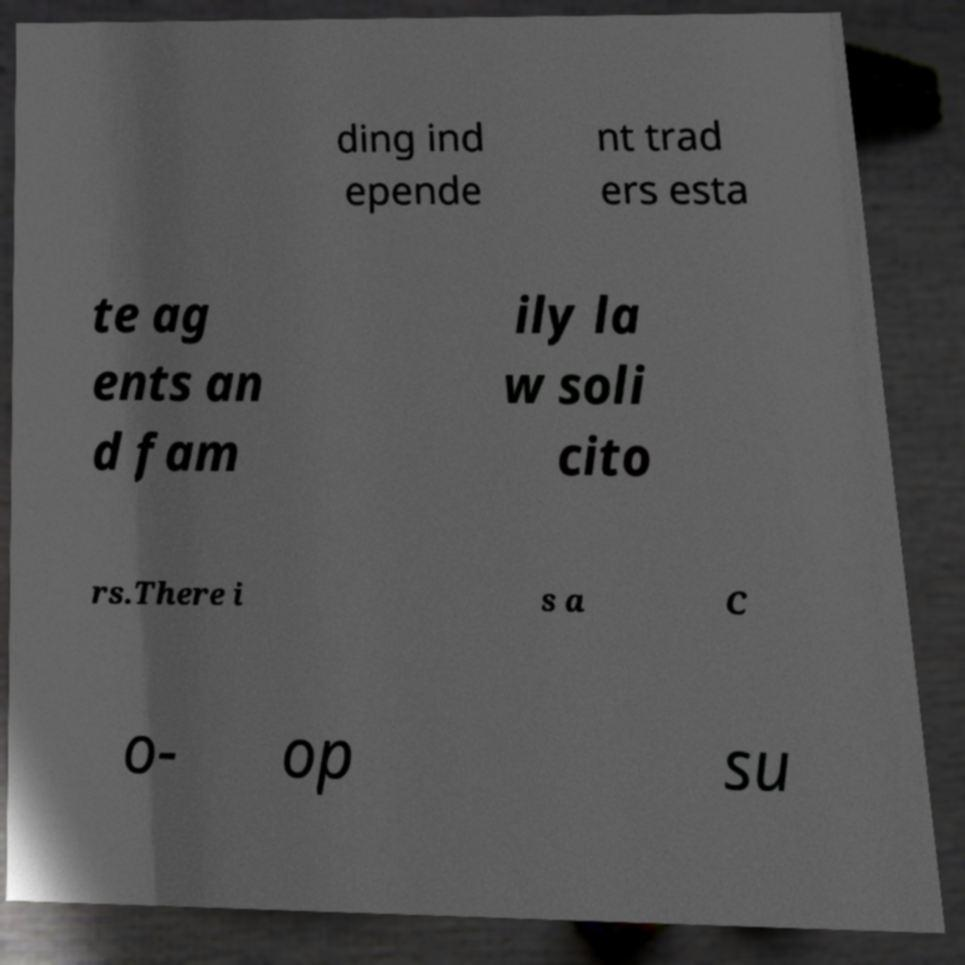There's text embedded in this image that I need extracted. Can you transcribe it verbatim? ding ind epende nt trad ers esta te ag ents an d fam ily la w soli cito rs.There i s a C o- op su 